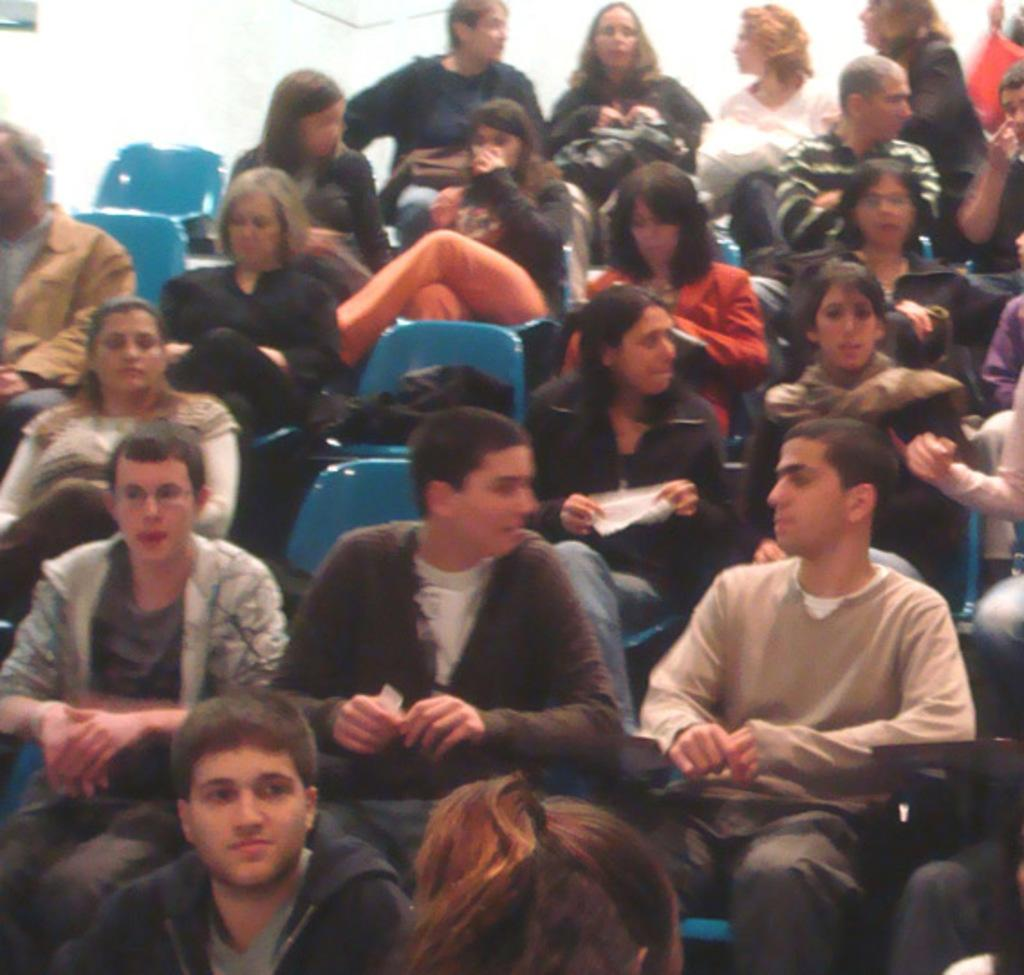What are the people in the image doing? The people in the image are sitting. Can you describe the gender distribution among the people? There are both women and men among the people in the image. Are there any available seats in the image? Yes, there are empty chairs in the image. What can be seen in the background of the image? There is a white wall in the background of the image. What type of furniture is being developed in the image? There is no furniture development taking place in the image; it features people sitting and a white wall in the background. Can you see any buns in the image? There are no buns present in the image. 